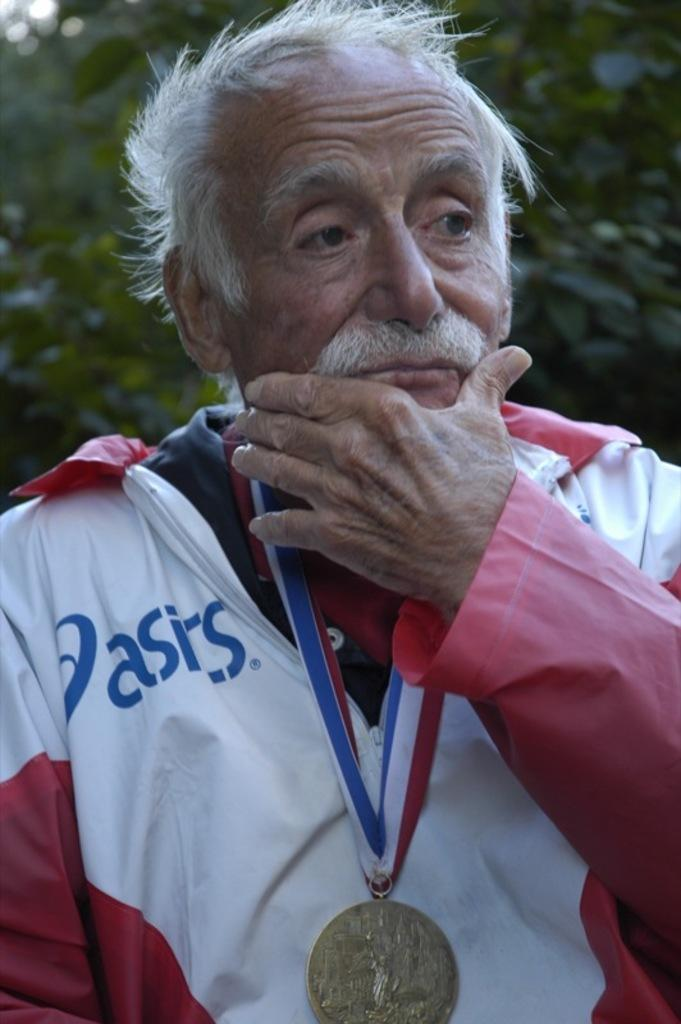<image>
Offer a succinct explanation of the picture presented. An older man with an Olympic medal is wearing an asics branded jacket. 